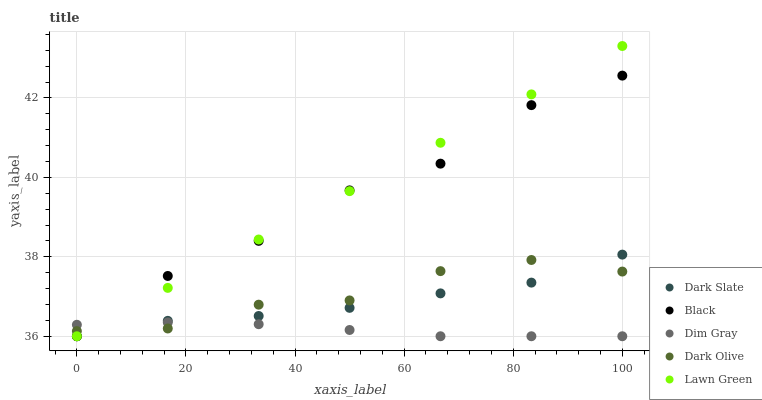Does Dim Gray have the minimum area under the curve?
Answer yes or no. Yes. Does Lawn Green have the maximum area under the curve?
Answer yes or no. Yes. Does Dark Slate have the minimum area under the curve?
Answer yes or no. No. Does Dark Slate have the maximum area under the curve?
Answer yes or no. No. Is Lawn Green the smoothest?
Answer yes or no. Yes. Is Black the roughest?
Answer yes or no. Yes. Is Dark Slate the smoothest?
Answer yes or no. No. Is Dark Slate the roughest?
Answer yes or no. No. Does Dark Slate have the lowest value?
Answer yes or no. Yes. Does Lawn Green have the highest value?
Answer yes or no. Yes. Does Dark Slate have the highest value?
Answer yes or no. No. Does Dim Gray intersect Black?
Answer yes or no. Yes. Is Dim Gray less than Black?
Answer yes or no. No. Is Dim Gray greater than Black?
Answer yes or no. No. 